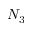Convert formula to latex. <formula><loc_0><loc_0><loc_500><loc_500>N _ { 3 }</formula> 